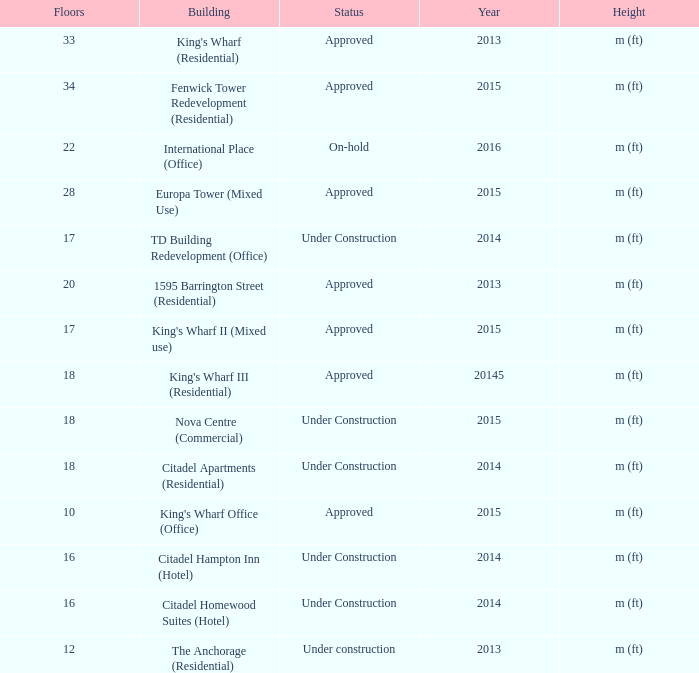What is the status of the building with less than 18 floors and later than 2013? Under Construction, Approved, Approved, Under Construction, Under Construction. 